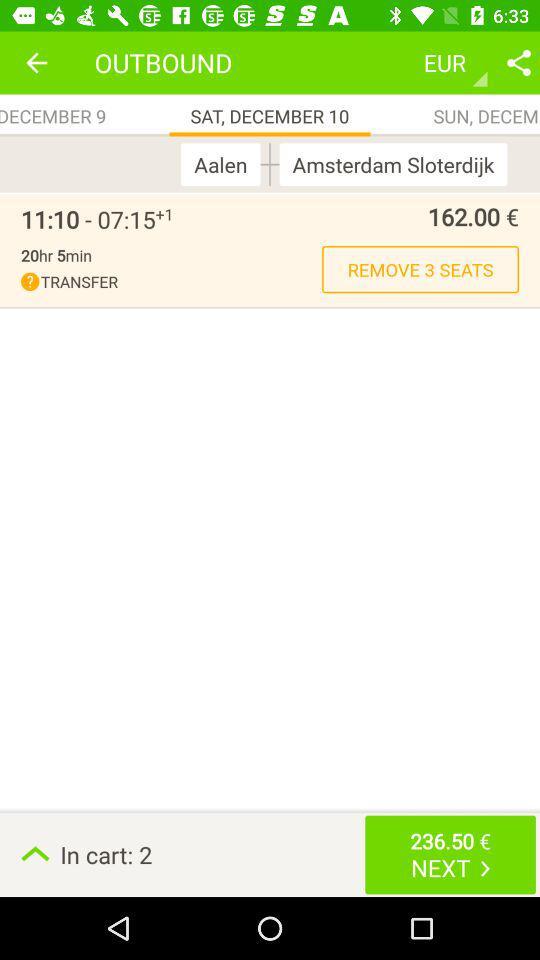Which day falls on December 10? The day is Saturday. 